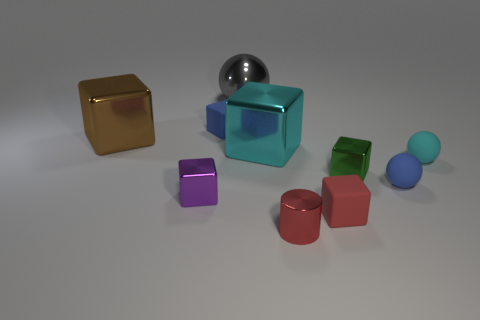Subtract all tiny purple metal blocks. How many blocks are left? 5 Subtract all brown blocks. How many blocks are left? 5 Subtract all blue cubes. Subtract all cyan cylinders. How many cubes are left? 5 Subtract all balls. How many objects are left? 7 Subtract all big brown metal objects. Subtract all tiny yellow metallic balls. How many objects are left? 9 Add 8 red cylinders. How many red cylinders are left? 9 Add 1 large brown things. How many large brown things exist? 2 Subtract 0 blue cylinders. How many objects are left? 10 